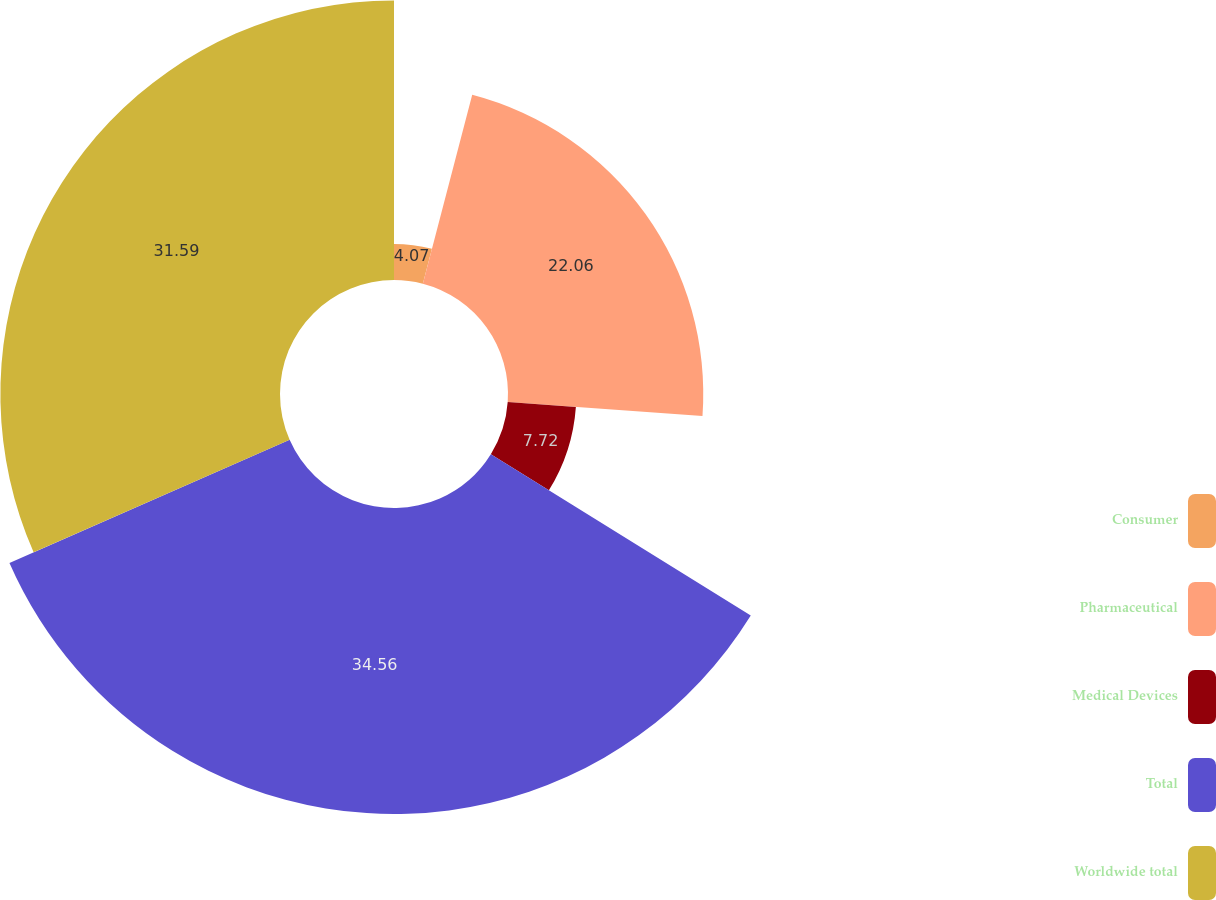Convert chart to OTSL. <chart><loc_0><loc_0><loc_500><loc_500><pie_chart><fcel>Consumer<fcel>Pharmaceutical<fcel>Medical Devices<fcel>Total<fcel>Worldwide total<nl><fcel>4.07%<fcel>22.06%<fcel>7.72%<fcel>34.57%<fcel>31.59%<nl></chart> 